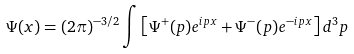<formula> <loc_0><loc_0><loc_500><loc_500>\Psi ( x ) = ( 2 \pi ) ^ { - 3 / 2 } \int \left [ \Psi ^ { + } ( p ) e ^ { i p x } + \Psi ^ { - } ( p ) e ^ { - i p x } \right ] d ^ { 3 } p</formula> 